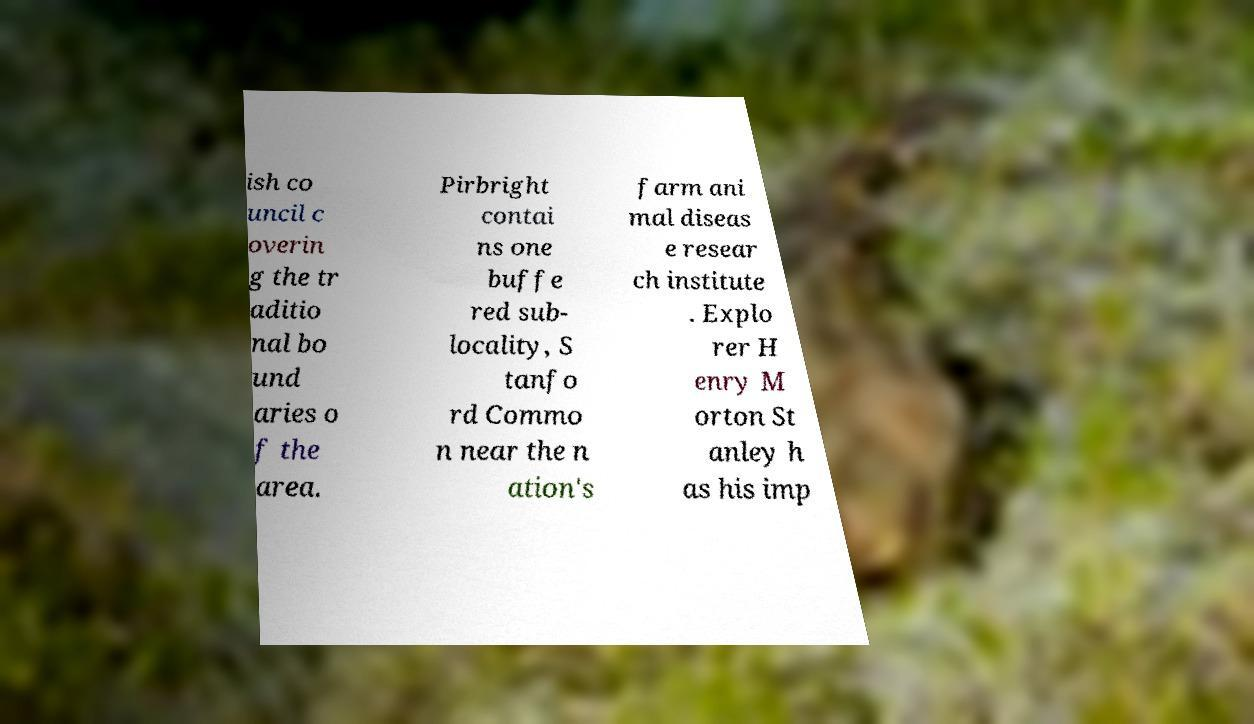Could you assist in decoding the text presented in this image and type it out clearly? ish co uncil c overin g the tr aditio nal bo und aries o f the area. Pirbright contai ns one buffe red sub- locality, S tanfo rd Commo n near the n ation's farm ani mal diseas e resear ch institute . Explo rer H enry M orton St anley h as his imp 